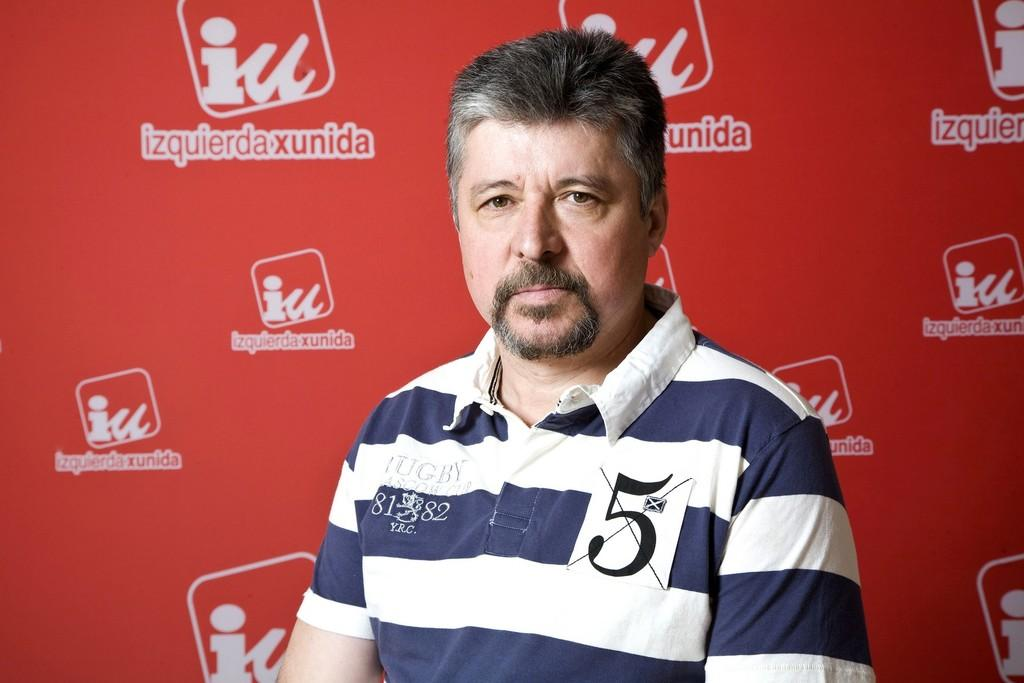Who is present in the image? There is a man in the image. What is the man wearing? The man is wearing a blue and white color T-shirt. What can be seen in the background of the image? There is a red color sheet in the background of the image. What type of pie is being distributed in the scene? There is no pie or distribution activity present in the image. 